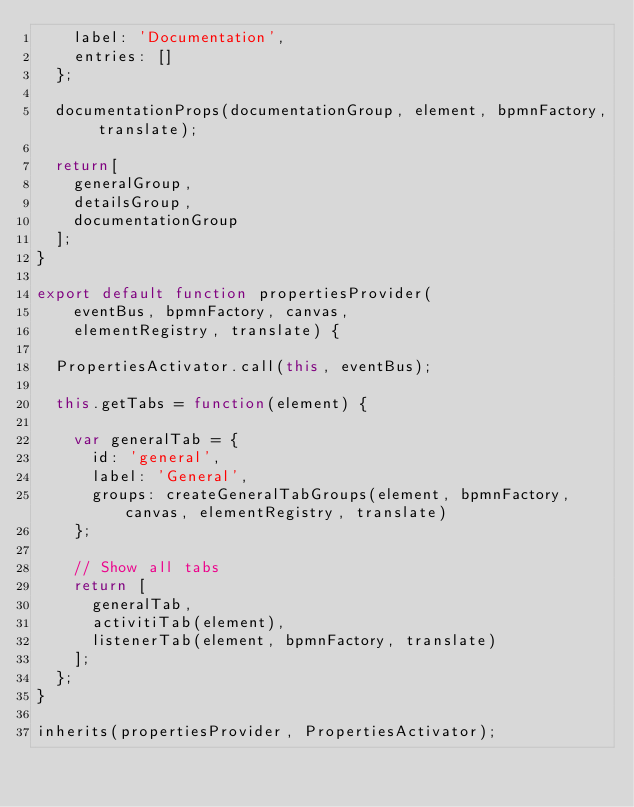<code> <loc_0><loc_0><loc_500><loc_500><_JavaScript_>    label: 'Documentation',
    entries: []
  };

  documentationProps(documentationGroup, element, bpmnFactory, translate);

  return[
    generalGroup,
    detailsGroup,
    documentationGroup
  ];
}

export default function propertiesProvider(
    eventBus, bpmnFactory, canvas,
    elementRegistry, translate) {

  PropertiesActivator.call(this, eventBus);

  this.getTabs = function(element) {

    var generalTab = {
      id: 'general',
      label: 'General',
      groups: createGeneralTabGroups(element, bpmnFactory, canvas, elementRegistry, translate)
    };

    // Show all tabs
    return [
      generalTab,
      activitiTab(element),
      listenerTab(element, bpmnFactory, translate)
    ];
  };
}

inherits(propertiesProvider, PropertiesActivator);</code> 